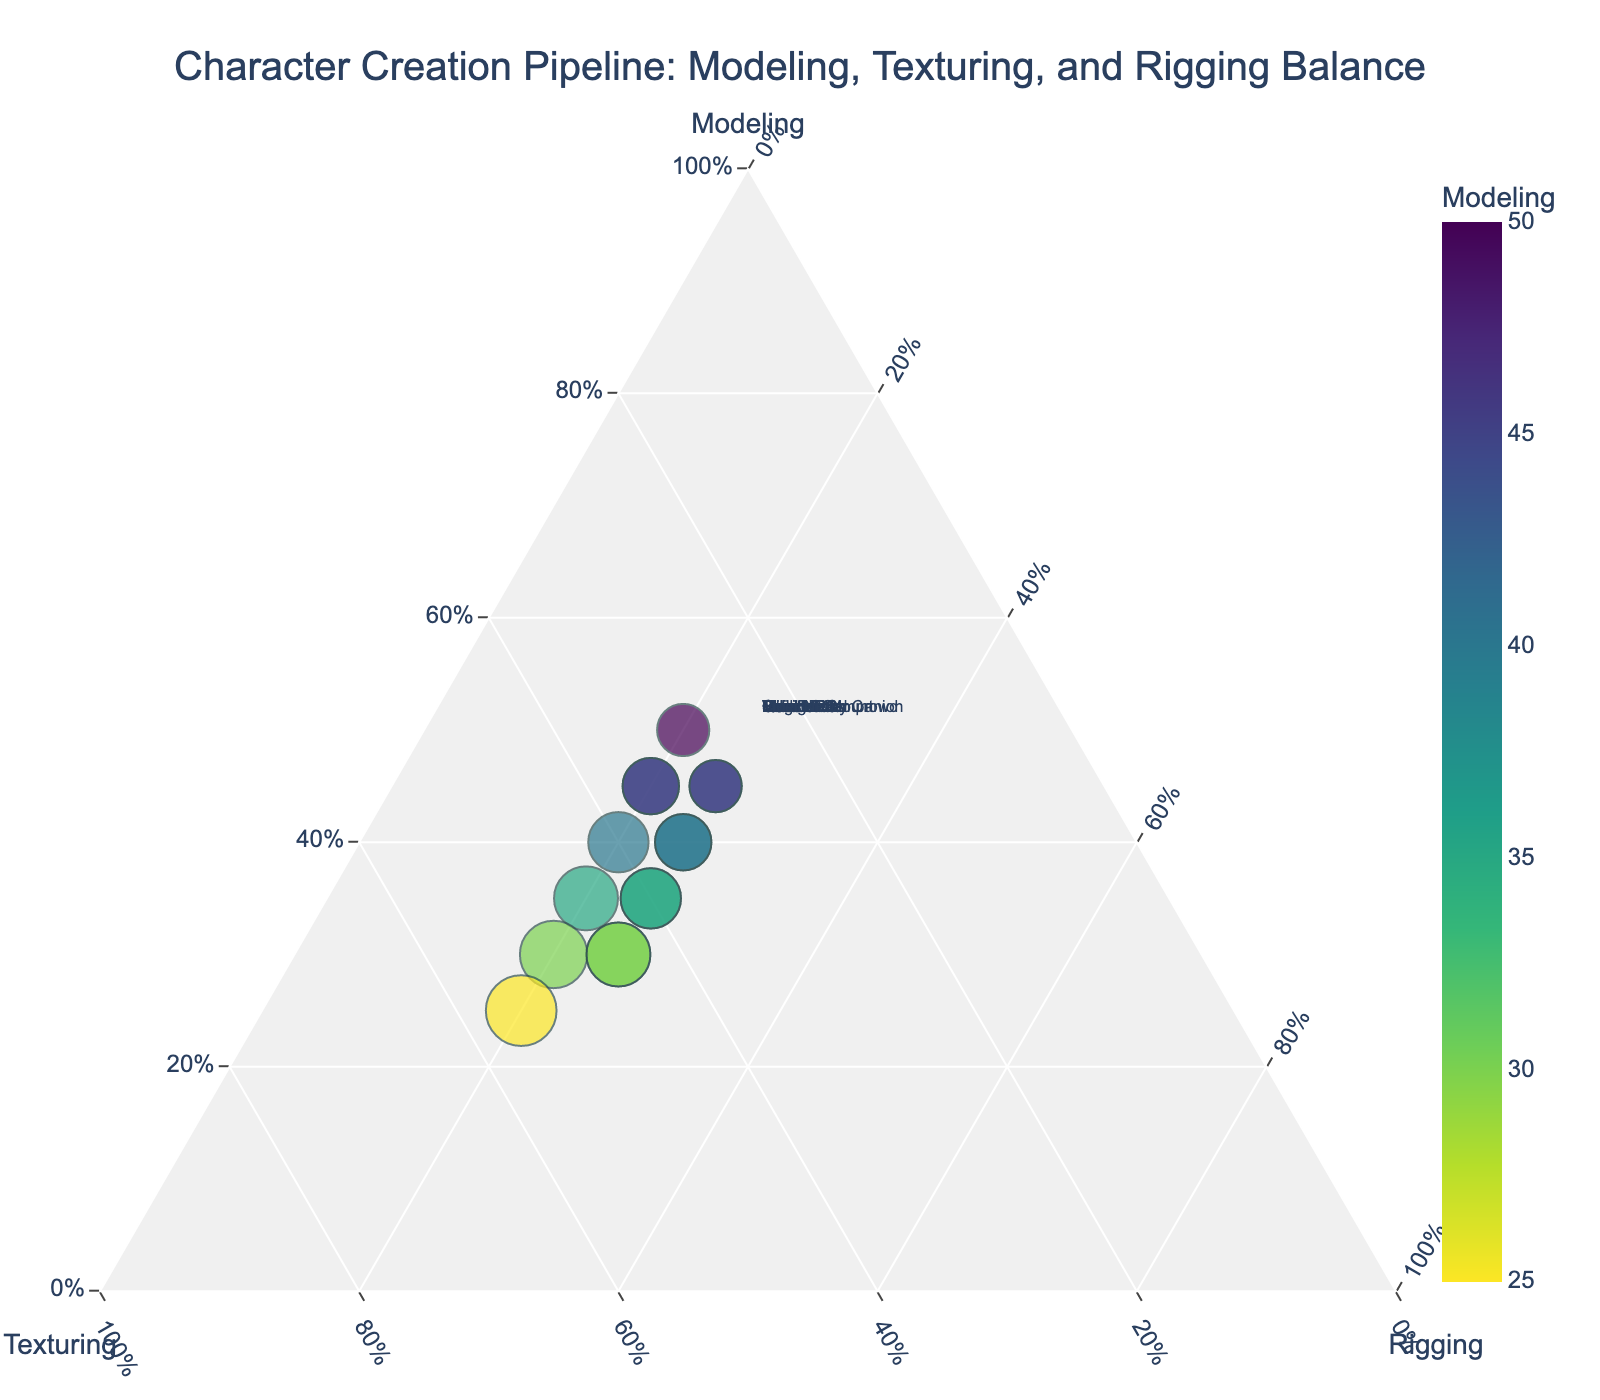What is the title of the figure? The title is usually placed at the top of the plot and immediately visible.
Answer: Character Creation Pipeline: Modeling, Texturing, and Rigging Balance Which character has the highest percentage allocated to Modeling? By observing the data points with the maximum distance towards the Modeling axis, we can identify the character.
Answer: Monster A How many characters have more than 40% of their time allocated to Texturing? Identify the points closest to the Texturing axis by checking the proportion of the total allocated to texturing.
Answer: 5 What is the character with the highest Modeling percentage that also has 20% allocated to Rigging? We need to identify the highest point closer to the Modeling axis filtered by 20% on the Rigging axis.
Answer: Monster A Which character spends an equal amount of time in Texturing and Modeling? We look for a point where the percentages for Modeling and Texturing are the same.
Answer: Guard For the character ‘Villain Boss,’ is more time spent on Modeling or Texturing? Locate the point for 'Villain Boss' and compare the distances from the Modeling and Texturing axes.
Answer: Modeling Which two characters allocate exactly 25% of their time to Rigging? Identify the data points aligned with the 25% marker on the Rigging axis.
Answer: Main Hero, Villain Boss What is the average percentage of time allocated to Rigging across all characters? Sum all the percentages for Rigging and divide by the number of characters.
Answer: 22.67% Which character is closest to evenly distributing time among Modeling, Texturing, and Rigging? Identify the points closest to the plot's center, where all three elements are balanced.
Answer: Main Hero Who spends the most time texturing, the Merchant or the Town NPC? Locate the points for each and compare their distances from the Texturing axis.
Answer: Town NPC 